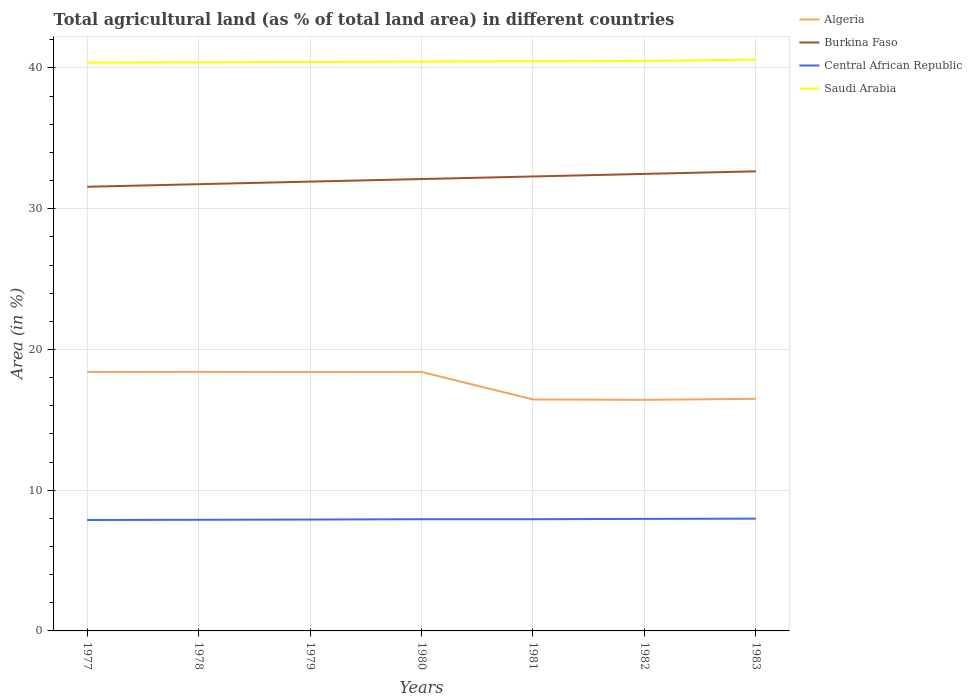How many different coloured lines are there?
Offer a terse response. 4. Does the line corresponding to Burkina Faso intersect with the line corresponding to Saudi Arabia?
Your answer should be very brief. No. Across all years, what is the maximum percentage of agricultural land in Burkina Faso?
Offer a very short reply. 31.56. What is the total percentage of agricultural land in Saudi Arabia in the graph?
Provide a short and direct response. -0.02. What is the difference between the highest and the second highest percentage of agricultural land in Burkina Faso?
Ensure brevity in your answer.  1.1. How many lines are there?
Offer a very short reply. 4. How are the legend labels stacked?
Keep it short and to the point. Vertical. What is the title of the graph?
Offer a very short reply. Total agricultural land (as % of total land area) in different countries. What is the label or title of the Y-axis?
Keep it short and to the point. Area (in %). What is the Area (in %) of Algeria in 1977?
Offer a terse response. 18.4. What is the Area (in %) in Burkina Faso in 1977?
Make the answer very short. 31.56. What is the Area (in %) of Central African Republic in 1977?
Offer a very short reply. 7.88. What is the Area (in %) of Saudi Arabia in 1977?
Provide a succinct answer. 40.38. What is the Area (in %) of Algeria in 1978?
Your answer should be compact. 18.41. What is the Area (in %) in Burkina Faso in 1978?
Your response must be concise. 31.74. What is the Area (in %) of Central African Republic in 1978?
Offer a terse response. 7.9. What is the Area (in %) in Saudi Arabia in 1978?
Keep it short and to the point. 40.4. What is the Area (in %) of Algeria in 1979?
Provide a succinct answer. 18.4. What is the Area (in %) of Burkina Faso in 1979?
Provide a succinct answer. 31.93. What is the Area (in %) of Central African Republic in 1979?
Your response must be concise. 7.91. What is the Area (in %) of Saudi Arabia in 1979?
Offer a very short reply. 40.43. What is the Area (in %) in Algeria in 1980?
Keep it short and to the point. 18.4. What is the Area (in %) of Burkina Faso in 1980?
Ensure brevity in your answer.  32.11. What is the Area (in %) in Central African Republic in 1980?
Make the answer very short. 7.94. What is the Area (in %) of Saudi Arabia in 1980?
Ensure brevity in your answer.  40.45. What is the Area (in %) of Algeria in 1981?
Provide a short and direct response. 16.45. What is the Area (in %) of Burkina Faso in 1981?
Offer a terse response. 32.29. What is the Area (in %) of Central African Republic in 1981?
Provide a succinct answer. 7.94. What is the Area (in %) of Saudi Arabia in 1981?
Keep it short and to the point. 40.48. What is the Area (in %) in Algeria in 1982?
Offer a terse response. 16.42. What is the Area (in %) in Burkina Faso in 1982?
Give a very brief answer. 32.47. What is the Area (in %) in Central African Republic in 1982?
Your answer should be compact. 7.96. What is the Area (in %) of Saudi Arabia in 1982?
Make the answer very short. 40.5. What is the Area (in %) of Algeria in 1983?
Make the answer very short. 16.49. What is the Area (in %) in Burkina Faso in 1983?
Provide a succinct answer. 32.66. What is the Area (in %) in Central African Republic in 1983?
Offer a terse response. 7.98. What is the Area (in %) in Saudi Arabia in 1983?
Ensure brevity in your answer.  40.6. Across all years, what is the maximum Area (in %) of Algeria?
Your answer should be compact. 18.41. Across all years, what is the maximum Area (in %) in Burkina Faso?
Keep it short and to the point. 32.66. Across all years, what is the maximum Area (in %) in Central African Republic?
Ensure brevity in your answer.  7.98. Across all years, what is the maximum Area (in %) of Saudi Arabia?
Offer a terse response. 40.6. Across all years, what is the minimum Area (in %) of Algeria?
Offer a terse response. 16.42. Across all years, what is the minimum Area (in %) of Burkina Faso?
Give a very brief answer. 31.56. Across all years, what is the minimum Area (in %) in Central African Republic?
Make the answer very short. 7.88. Across all years, what is the minimum Area (in %) in Saudi Arabia?
Your response must be concise. 40.38. What is the total Area (in %) in Algeria in the graph?
Give a very brief answer. 122.97. What is the total Area (in %) of Burkina Faso in the graph?
Your response must be concise. 224.76. What is the total Area (in %) of Central African Republic in the graph?
Keep it short and to the point. 55.51. What is the total Area (in %) of Saudi Arabia in the graph?
Keep it short and to the point. 283.24. What is the difference between the Area (in %) in Algeria in 1977 and that in 1978?
Your answer should be very brief. -0. What is the difference between the Area (in %) of Burkina Faso in 1977 and that in 1978?
Offer a very short reply. -0.18. What is the difference between the Area (in %) of Central African Republic in 1977 and that in 1978?
Keep it short and to the point. -0.02. What is the difference between the Area (in %) of Saudi Arabia in 1977 and that in 1978?
Your answer should be compact. -0.02. What is the difference between the Area (in %) in Algeria in 1977 and that in 1979?
Offer a terse response. 0.01. What is the difference between the Area (in %) of Burkina Faso in 1977 and that in 1979?
Ensure brevity in your answer.  -0.37. What is the difference between the Area (in %) in Central African Republic in 1977 and that in 1979?
Ensure brevity in your answer.  -0.03. What is the difference between the Area (in %) of Saudi Arabia in 1977 and that in 1979?
Keep it short and to the point. -0.05. What is the difference between the Area (in %) of Algeria in 1977 and that in 1980?
Offer a terse response. 0. What is the difference between the Area (in %) of Burkina Faso in 1977 and that in 1980?
Provide a succinct answer. -0.55. What is the difference between the Area (in %) of Central African Republic in 1977 and that in 1980?
Provide a succinct answer. -0.06. What is the difference between the Area (in %) of Saudi Arabia in 1977 and that in 1980?
Your answer should be compact. -0.07. What is the difference between the Area (in %) of Algeria in 1977 and that in 1981?
Ensure brevity in your answer.  1.96. What is the difference between the Area (in %) in Burkina Faso in 1977 and that in 1981?
Your answer should be compact. -0.73. What is the difference between the Area (in %) in Central African Republic in 1977 and that in 1981?
Provide a succinct answer. -0.06. What is the difference between the Area (in %) in Saudi Arabia in 1977 and that in 1981?
Ensure brevity in your answer.  -0.1. What is the difference between the Area (in %) in Algeria in 1977 and that in 1982?
Give a very brief answer. 1.98. What is the difference between the Area (in %) of Burkina Faso in 1977 and that in 1982?
Make the answer very short. -0.91. What is the difference between the Area (in %) in Central African Republic in 1977 and that in 1982?
Your response must be concise. -0.08. What is the difference between the Area (in %) of Saudi Arabia in 1977 and that in 1982?
Offer a very short reply. -0.12. What is the difference between the Area (in %) in Algeria in 1977 and that in 1983?
Offer a very short reply. 1.91. What is the difference between the Area (in %) of Burkina Faso in 1977 and that in 1983?
Give a very brief answer. -1.1. What is the difference between the Area (in %) in Central African Republic in 1977 and that in 1983?
Keep it short and to the point. -0.1. What is the difference between the Area (in %) of Saudi Arabia in 1977 and that in 1983?
Keep it short and to the point. -0.22. What is the difference between the Area (in %) of Algeria in 1978 and that in 1979?
Give a very brief answer. 0.01. What is the difference between the Area (in %) in Burkina Faso in 1978 and that in 1979?
Your answer should be compact. -0.18. What is the difference between the Area (in %) of Central African Republic in 1978 and that in 1979?
Provide a short and direct response. -0.02. What is the difference between the Area (in %) of Saudi Arabia in 1978 and that in 1979?
Provide a short and direct response. -0.02. What is the difference between the Area (in %) in Algeria in 1978 and that in 1980?
Give a very brief answer. 0.01. What is the difference between the Area (in %) of Burkina Faso in 1978 and that in 1980?
Make the answer very short. -0.37. What is the difference between the Area (in %) in Central African Republic in 1978 and that in 1980?
Provide a succinct answer. -0.04. What is the difference between the Area (in %) in Saudi Arabia in 1978 and that in 1980?
Provide a short and direct response. -0.05. What is the difference between the Area (in %) in Algeria in 1978 and that in 1981?
Your answer should be very brief. 1.96. What is the difference between the Area (in %) of Burkina Faso in 1978 and that in 1981?
Give a very brief answer. -0.55. What is the difference between the Area (in %) of Central African Republic in 1978 and that in 1981?
Your response must be concise. -0.04. What is the difference between the Area (in %) in Saudi Arabia in 1978 and that in 1981?
Your answer should be compact. -0.07. What is the difference between the Area (in %) of Algeria in 1978 and that in 1982?
Provide a succinct answer. 1.99. What is the difference between the Area (in %) in Burkina Faso in 1978 and that in 1982?
Your answer should be very brief. -0.73. What is the difference between the Area (in %) of Central African Republic in 1978 and that in 1982?
Give a very brief answer. -0.06. What is the difference between the Area (in %) in Saudi Arabia in 1978 and that in 1982?
Your response must be concise. -0.1. What is the difference between the Area (in %) in Algeria in 1978 and that in 1983?
Offer a terse response. 1.92. What is the difference between the Area (in %) of Burkina Faso in 1978 and that in 1983?
Provide a succinct answer. -0.91. What is the difference between the Area (in %) of Central African Republic in 1978 and that in 1983?
Your response must be concise. -0.08. What is the difference between the Area (in %) of Saudi Arabia in 1978 and that in 1983?
Ensure brevity in your answer.  -0.19. What is the difference between the Area (in %) of Algeria in 1979 and that in 1980?
Provide a succinct answer. -0. What is the difference between the Area (in %) of Burkina Faso in 1979 and that in 1980?
Keep it short and to the point. -0.18. What is the difference between the Area (in %) in Central African Republic in 1979 and that in 1980?
Provide a short and direct response. -0.02. What is the difference between the Area (in %) in Saudi Arabia in 1979 and that in 1980?
Offer a terse response. -0.02. What is the difference between the Area (in %) of Algeria in 1979 and that in 1981?
Provide a succinct answer. 1.95. What is the difference between the Area (in %) in Burkina Faso in 1979 and that in 1981?
Provide a succinct answer. -0.37. What is the difference between the Area (in %) of Central African Republic in 1979 and that in 1981?
Make the answer very short. -0.02. What is the difference between the Area (in %) in Saudi Arabia in 1979 and that in 1981?
Offer a terse response. -0.05. What is the difference between the Area (in %) of Algeria in 1979 and that in 1982?
Your answer should be very brief. 1.98. What is the difference between the Area (in %) of Burkina Faso in 1979 and that in 1982?
Ensure brevity in your answer.  -0.55. What is the difference between the Area (in %) in Central African Republic in 1979 and that in 1982?
Offer a terse response. -0.05. What is the difference between the Area (in %) of Saudi Arabia in 1979 and that in 1982?
Offer a very short reply. -0.07. What is the difference between the Area (in %) in Algeria in 1979 and that in 1983?
Provide a succinct answer. 1.91. What is the difference between the Area (in %) in Burkina Faso in 1979 and that in 1983?
Provide a short and direct response. -0.73. What is the difference between the Area (in %) of Central African Republic in 1979 and that in 1983?
Make the answer very short. -0.06. What is the difference between the Area (in %) of Saudi Arabia in 1979 and that in 1983?
Your answer should be compact. -0.17. What is the difference between the Area (in %) in Algeria in 1980 and that in 1981?
Ensure brevity in your answer.  1.96. What is the difference between the Area (in %) of Burkina Faso in 1980 and that in 1981?
Your answer should be compact. -0.18. What is the difference between the Area (in %) in Central African Republic in 1980 and that in 1981?
Provide a short and direct response. 0. What is the difference between the Area (in %) of Saudi Arabia in 1980 and that in 1981?
Ensure brevity in your answer.  -0.02. What is the difference between the Area (in %) in Algeria in 1980 and that in 1982?
Offer a very short reply. 1.98. What is the difference between the Area (in %) in Burkina Faso in 1980 and that in 1982?
Provide a short and direct response. -0.37. What is the difference between the Area (in %) of Central African Republic in 1980 and that in 1982?
Your answer should be very brief. -0.02. What is the difference between the Area (in %) of Saudi Arabia in 1980 and that in 1982?
Your answer should be compact. -0.05. What is the difference between the Area (in %) of Algeria in 1980 and that in 1983?
Give a very brief answer. 1.91. What is the difference between the Area (in %) in Burkina Faso in 1980 and that in 1983?
Offer a terse response. -0.55. What is the difference between the Area (in %) in Central African Republic in 1980 and that in 1983?
Your response must be concise. -0.04. What is the difference between the Area (in %) in Saudi Arabia in 1980 and that in 1983?
Provide a short and direct response. -0.14. What is the difference between the Area (in %) in Algeria in 1981 and that in 1982?
Offer a terse response. 0.03. What is the difference between the Area (in %) of Burkina Faso in 1981 and that in 1982?
Offer a very short reply. -0.18. What is the difference between the Area (in %) of Central African Republic in 1981 and that in 1982?
Make the answer very short. -0.02. What is the difference between the Area (in %) in Saudi Arabia in 1981 and that in 1982?
Provide a succinct answer. -0.03. What is the difference between the Area (in %) in Algeria in 1981 and that in 1983?
Offer a terse response. -0.05. What is the difference between the Area (in %) of Burkina Faso in 1981 and that in 1983?
Give a very brief answer. -0.37. What is the difference between the Area (in %) in Central African Republic in 1981 and that in 1983?
Offer a very short reply. -0.04. What is the difference between the Area (in %) in Saudi Arabia in 1981 and that in 1983?
Keep it short and to the point. -0.12. What is the difference between the Area (in %) of Algeria in 1982 and that in 1983?
Offer a very short reply. -0.07. What is the difference between the Area (in %) of Burkina Faso in 1982 and that in 1983?
Provide a short and direct response. -0.18. What is the difference between the Area (in %) of Central African Republic in 1982 and that in 1983?
Your answer should be very brief. -0.02. What is the difference between the Area (in %) in Saudi Arabia in 1982 and that in 1983?
Your answer should be compact. -0.09. What is the difference between the Area (in %) in Algeria in 1977 and the Area (in %) in Burkina Faso in 1978?
Give a very brief answer. -13.34. What is the difference between the Area (in %) of Algeria in 1977 and the Area (in %) of Central African Republic in 1978?
Offer a very short reply. 10.51. What is the difference between the Area (in %) of Algeria in 1977 and the Area (in %) of Saudi Arabia in 1978?
Offer a very short reply. -22. What is the difference between the Area (in %) in Burkina Faso in 1977 and the Area (in %) in Central African Republic in 1978?
Your answer should be compact. 23.66. What is the difference between the Area (in %) in Burkina Faso in 1977 and the Area (in %) in Saudi Arabia in 1978?
Offer a very short reply. -8.84. What is the difference between the Area (in %) in Central African Republic in 1977 and the Area (in %) in Saudi Arabia in 1978?
Your answer should be compact. -32.52. What is the difference between the Area (in %) of Algeria in 1977 and the Area (in %) of Burkina Faso in 1979?
Your answer should be compact. -13.52. What is the difference between the Area (in %) of Algeria in 1977 and the Area (in %) of Central African Republic in 1979?
Offer a terse response. 10.49. What is the difference between the Area (in %) of Algeria in 1977 and the Area (in %) of Saudi Arabia in 1979?
Provide a short and direct response. -22.03. What is the difference between the Area (in %) of Burkina Faso in 1977 and the Area (in %) of Central African Republic in 1979?
Provide a short and direct response. 23.65. What is the difference between the Area (in %) of Burkina Faso in 1977 and the Area (in %) of Saudi Arabia in 1979?
Offer a very short reply. -8.87. What is the difference between the Area (in %) of Central African Republic in 1977 and the Area (in %) of Saudi Arabia in 1979?
Your response must be concise. -32.55. What is the difference between the Area (in %) of Algeria in 1977 and the Area (in %) of Burkina Faso in 1980?
Ensure brevity in your answer.  -13.71. What is the difference between the Area (in %) of Algeria in 1977 and the Area (in %) of Central African Republic in 1980?
Make the answer very short. 10.47. What is the difference between the Area (in %) in Algeria in 1977 and the Area (in %) in Saudi Arabia in 1980?
Offer a terse response. -22.05. What is the difference between the Area (in %) of Burkina Faso in 1977 and the Area (in %) of Central African Republic in 1980?
Give a very brief answer. 23.62. What is the difference between the Area (in %) of Burkina Faso in 1977 and the Area (in %) of Saudi Arabia in 1980?
Your response must be concise. -8.89. What is the difference between the Area (in %) in Central African Republic in 1977 and the Area (in %) in Saudi Arabia in 1980?
Offer a very short reply. -32.57. What is the difference between the Area (in %) of Algeria in 1977 and the Area (in %) of Burkina Faso in 1981?
Provide a short and direct response. -13.89. What is the difference between the Area (in %) of Algeria in 1977 and the Area (in %) of Central African Republic in 1981?
Offer a very short reply. 10.47. What is the difference between the Area (in %) of Algeria in 1977 and the Area (in %) of Saudi Arabia in 1981?
Make the answer very short. -22.07. What is the difference between the Area (in %) in Burkina Faso in 1977 and the Area (in %) in Central African Republic in 1981?
Your answer should be very brief. 23.62. What is the difference between the Area (in %) in Burkina Faso in 1977 and the Area (in %) in Saudi Arabia in 1981?
Your answer should be compact. -8.92. What is the difference between the Area (in %) of Central African Republic in 1977 and the Area (in %) of Saudi Arabia in 1981?
Keep it short and to the point. -32.6. What is the difference between the Area (in %) of Algeria in 1977 and the Area (in %) of Burkina Faso in 1982?
Your response must be concise. -14.07. What is the difference between the Area (in %) of Algeria in 1977 and the Area (in %) of Central African Republic in 1982?
Ensure brevity in your answer.  10.44. What is the difference between the Area (in %) of Algeria in 1977 and the Area (in %) of Saudi Arabia in 1982?
Ensure brevity in your answer.  -22.1. What is the difference between the Area (in %) in Burkina Faso in 1977 and the Area (in %) in Central African Republic in 1982?
Offer a terse response. 23.6. What is the difference between the Area (in %) in Burkina Faso in 1977 and the Area (in %) in Saudi Arabia in 1982?
Your answer should be very brief. -8.94. What is the difference between the Area (in %) in Central African Republic in 1977 and the Area (in %) in Saudi Arabia in 1982?
Make the answer very short. -32.62. What is the difference between the Area (in %) in Algeria in 1977 and the Area (in %) in Burkina Faso in 1983?
Keep it short and to the point. -14.25. What is the difference between the Area (in %) of Algeria in 1977 and the Area (in %) of Central African Republic in 1983?
Your response must be concise. 10.43. What is the difference between the Area (in %) in Algeria in 1977 and the Area (in %) in Saudi Arabia in 1983?
Offer a very short reply. -22.19. What is the difference between the Area (in %) of Burkina Faso in 1977 and the Area (in %) of Central African Republic in 1983?
Your answer should be compact. 23.58. What is the difference between the Area (in %) in Burkina Faso in 1977 and the Area (in %) in Saudi Arabia in 1983?
Give a very brief answer. -9.04. What is the difference between the Area (in %) in Central African Republic in 1977 and the Area (in %) in Saudi Arabia in 1983?
Provide a short and direct response. -32.72. What is the difference between the Area (in %) in Algeria in 1978 and the Area (in %) in Burkina Faso in 1979?
Provide a succinct answer. -13.52. What is the difference between the Area (in %) of Algeria in 1978 and the Area (in %) of Central African Republic in 1979?
Provide a succinct answer. 10.49. What is the difference between the Area (in %) of Algeria in 1978 and the Area (in %) of Saudi Arabia in 1979?
Offer a terse response. -22.02. What is the difference between the Area (in %) of Burkina Faso in 1978 and the Area (in %) of Central African Republic in 1979?
Provide a short and direct response. 23.83. What is the difference between the Area (in %) in Burkina Faso in 1978 and the Area (in %) in Saudi Arabia in 1979?
Give a very brief answer. -8.69. What is the difference between the Area (in %) of Central African Republic in 1978 and the Area (in %) of Saudi Arabia in 1979?
Your answer should be very brief. -32.53. What is the difference between the Area (in %) in Algeria in 1978 and the Area (in %) in Burkina Faso in 1980?
Ensure brevity in your answer.  -13.7. What is the difference between the Area (in %) of Algeria in 1978 and the Area (in %) of Central African Republic in 1980?
Your response must be concise. 10.47. What is the difference between the Area (in %) in Algeria in 1978 and the Area (in %) in Saudi Arabia in 1980?
Provide a succinct answer. -22.05. What is the difference between the Area (in %) in Burkina Faso in 1978 and the Area (in %) in Central African Republic in 1980?
Your answer should be very brief. 23.81. What is the difference between the Area (in %) in Burkina Faso in 1978 and the Area (in %) in Saudi Arabia in 1980?
Give a very brief answer. -8.71. What is the difference between the Area (in %) of Central African Republic in 1978 and the Area (in %) of Saudi Arabia in 1980?
Provide a short and direct response. -32.56. What is the difference between the Area (in %) in Algeria in 1978 and the Area (in %) in Burkina Faso in 1981?
Your response must be concise. -13.88. What is the difference between the Area (in %) in Algeria in 1978 and the Area (in %) in Central African Republic in 1981?
Offer a terse response. 10.47. What is the difference between the Area (in %) of Algeria in 1978 and the Area (in %) of Saudi Arabia in 1981?
Provide a short and direct response. -22.07. What is the difference between the Area (in %) of Burkina Faso in 1978 and the Area (in %) of Central African Republic in 1981?
Provide a succinct answer. 23.81. What is the difference between the Area (in %) in Burkina Faso in 1978 and the Area (in %) in Saudi Arabia in 1981?
Keep it short and to the point. -8.73. What is the difference between the Area (in %) in Central African Republic in 1978 and the Area (in %) in Saudi Arabia in 1981?
Offer a very short reply. -32.58. What is the difference between the Area (in %) in Algeria in 1978 and the Area (in %) in Burkina Faso in 1982?
Your answer should be compact. -14.07. What is the difference between the Area (in %) in Algeria in 1978 and the Area (in %) in Central African Republic in 1982?
Provide a succinct answer. 10.45. What is the difference between the Area (in %) in Algeria in 1978 and the Area (in %) in Saudi Arabia in 1982?
Your response must be concise. -22.09. What is the difference between the Area (in %) in Burkina Faso in 1978 and the Area (in %) in Central African Republic in 1982?
Provide a short and direct response. 23.78. What is the difference between the Area (in %) of Burkina Faso in 1978 and the Area (in %) of Saudi Arabia in 1982?
Your response must be concise. -8.76. What is the difference between the Area (in %) in Central African Republic in 1978 and the Area (in %) in Saudi Arabia in 1982?
Your response must be concise. -32.61. What is the difference between the Area (in %) of Algeria in 1978 and the Area (in %) of Burkina Faso in 1983?
Offer a terse response. -14.25. What is the difference between the Area (in %) of Algeria in 1978 and the Area (in %) of Central African Republic in 1983?
Ensure brevity in your answer.  10.43. What is the difference between the Area (in %) of Algeria in 1978 and the Area (in %) of Saudi Arabia in 1983?
Ensure brevity in your answer.  -22.19. What is the difference between the Area (in %) in Burkina Faso in 1978 and the Area (in %) in Central African Republic in 1983?
Your response must be concise. 23.77. What is the difference between the Area (in %) in Burkina Faso in 1978 and the Area (in %) in Saudi Arabia in 1983?
Keep it short and to the point. -8.85. What is the difference between the Area (in %) in Central African Republic in 1978 and the Area (in %) in Saudi Arabia in 1983?
Offer a terse response. -32.7. What is the difference between the Area (in %) in Algeria in 1979 and the Area (in %) in Burkina Faso in 1980?
Your answer should be compact. -13.71. What is the difference between the Area (in %) of Algeria in 1979 and the Area (in %) of Central African Republic in 1980?
Ensure brevity in your answer.  10.46. What is the difference between the Area (in %) in Algeria in 1979 and the Area (in %) in Saudi Arabia in 1980?
Ensure brevity in your answer.  -22.05. What is the difference between the Area (in %) of Burkina Faso in 1979 and the Area (in %) of Central African Republic in 1980?
Offer a terse response. 23.99. What is the difference between the Area (in %) of Burkina Faso in 1979 and the Area (in %) of Saudi Arabia in 1980?
Offer a very short reply. -8.53. What is the difference between the Area (in %) in Central African Republic in 1979 and the Area (in %) in Saudi Arabia in 1980?
Keep it short and to the point. -32.54. What is the difference between the Area (in %) in Algeria in 1979 and the Area (in %) in Burkina Faso in 1981?
Keep it short and to the point. -13.89. What is the difference between the Area (in %) in Algeria in 1979 and the Area (in %) in Central African Republic in 1981?
Provide a succinct answer. 10.46. What is the difference between the Area (in %) of Algeria in 1979 and the Area (in %) of Saudi Arabia in 1981?
Your response must be concise. -22.08. What is the difference between the Area (in %) in Burkina Faso in 1979 and the Area (in %) in Central African Republic in 1981?
Give a very brief answer. 23.99. What is the difference between the Area (in %) of Burkina Faso in 1979 and the Area (in %) of Saudi Arabia in 1981?
Keep it short and to the point. -8.55. What is the difference between the Area (in %) of Central African Republic in 1979 and the Area (in %) of Saudi Arabia in 1981?
Offer a very short reply. -32.56. What is the difference between the Area (in %) in Algeria in 1979 and the Area (in %) in Burkina Faso in 1982?
Offer a very short reply. -14.08. What is the difference between the Area (in %) of Algeria in 1979 and the Area (in %) of Central African Republic in 1982?
Give a very brief answer. 10.44. What is the difference between the Area (in %) of Algeria in 1979 and the Area (in %) of Saudi Arabia in 1982?
Give a very brief answer. -22.1. What is the difference between the Area (in %) of Burkina Faso in 1979 and the Area (in %) of Central African Republic in 1982?
Offer a terse response. 23.96. What is the difference between the Area (in %) in Burkina Faso in 1979 and the Area (in %) in Saudi Arabia in 1982?
Give a very brief answer. -8.58. What is the difference between the Area (in %) of Central African Republic in 1979 and the Area (in %) of Saudi Arabia in 1982?
Offer a very short reply. -32.59. What is the difference between the Area (in %) in Algeria in 1979 and the Area (in %) in Burkina Faso in 1983?
Keep it short and to the point. -14.26. What is the difference between the Area (in %) of Algeria in 1979 and the Area (in %) of Central African Republic in 1983?
Keep it short and to the point. 10.42. What is the difference between the Area (in %) of Algeria in 1979 and the Area (in %) of Saudi Arabia in 1983?
Give a very brief answer. -22.2. What is the difference between the Area (in %) in Burkina Faso in 1979 and the Area (in %) in Central African Republic in 1983?
Give a very brief answer. 23.95. What is the difference between the Area (in %) in Burkina Faso in 1979 and the Area (in %) in Saudi Arabia in 1983?
Offer a terse response. -8.67. What is the difference between the Area (in %) in Central African Republic in 1979 and the Area (in %) in Saudi Arabia in 1983?
Offer a terse response. -32.68. What is the difference between the Area (in %) of Algeria in 1980 and the Area (in %) of Burkina Faso in 1981?
Ensure brevity in your answer.  -13.89. What is the difference between the Area (in %) in Algeria in 1980 and the Area (in %) in Central African Republic in 1981?
Provide a short and direct response. 10.46. What is the difference between the Area (in %) in Algeria in 1980 and the Area (in %) in Saudi Arabia in 1981?
Your answer should be very brief. -22.07. What is the difference between the Area (in %) in Burkina Faso in 1980 and the Area (in %) in Central African Republic in 1981?
Give a very brief answer. 24.17. What is the difference between the Area (in %) of Burkina Faso in 1980 and the Area (in %) of Saudi Arabia in 1981?
Your response must be concise. -8.37. What is the difference between the Area (in %) of Central African Republic in 1980 and the Area (in %) of Saudi Arabia in 1981?
Make the answer very short. -32.54. What is the difference between the Area (in %) of Algeria in 1980 and the Area (in %) of Burkina Faso in 1982?
Ensure brevity in your answer.  -14.07. What is the difference between the Area (in %) of Algeria in 1980 and the Area (in %) of Central African Republic in 1982?
Provide a succinct answer. 10.44. What is the difference between the Area (in %) of Algeria in 1980 and the Area (in %) of Saudi Arabia in 1982?
Offer a terse response. -22.1. What is the difference between the Area (in %) in Burkina Faso in 1980 and the Area (in %) in Central African Republic in 1982?
Your answer should be compact. 24.15. What is the difference between the Area (in %) of Burkina Faso in 1980 and the Area (in %) of Saudi Arabia in 1982?
Provide a succinct answer. -8.39. What is the difference between the Area (in %) in Central African Republic in 1980 and the Area (in %) in Saudi Arabia in 1982?
Provide a succinct answer. -32.56. What is the difference between the Area (in %) in Algeria in 1980 and the Area (in %) in Burkina Faso in 1983?
Your answer should be very brief. -14.25. What is the difference between the Area (in %) of Algeria in 1980 and the Area (in %) of Central African Republic in 1983?
Give a very brief answer. 10.42. What is the difference between the Area (in %) of Algeria in 1980 and the Area (in %) of Saudi Arabia in 1983?
Make the answer very short. -22.19. What is the difference between the Area (in %) of Burkina Faso in 1980 and the Area (in %) of Central African Republic in 1983?
Offer a very short reply. 24.13. What is the difference between the Area (in %) in Burkina Faso in 1980 and the Area (in %) in Saudi Arabia in 1983?
Ensure brevity in your answer.  -8.49. What is the difference between the Area (in %) in Central African Republic in 1980 and the Area (in %) in Saudi Arabia in 1983?
Make the answer very short. -32.66. What is the difference between the Area (in %) of Algeria in 1981 and the Area (in %) of Burkina Faso in 1982?
Offer a very short reply. -16.03. What is the difference between the Area (in %) in Algeria in 1981 and the Area (in %) in Central African Republic in 1982?
Your answer should be compact. 8.48. What is the difference between the Area (in %) in Algeria in 1981 and the Area (in %) in Saudi Arabia in 1982?
Offer a terse response. -24.06. What is the difference between the Area (in %) in Burkina Faso in 1981 and the Area (in %) in Central African Republic in 1982?
Your answer should be very brief. 24.33. What is the difference between the Area (in %) of Burkina Faso in 1981 and the Area (in %) of Saudi Arabia in 1982?
Ensure brevity in your answer.  -8.21. What is the difference between the Area (in %) of Central African Republic in 1981 and the Area (in %) of Saudi Arabia in 1982?
Your response must be concise. -32.56. What is the difference between the Area (in %) in Algeria in 1981 and the Area (in %) in Burkina Faso in 1983?
Ensure brevity in your answer.  -16.21. What is the difference between the Area (in %) in Algeria in 1981 and the Area (in %) in Central African Republic in 1983?
Offer a terse response. 8.47. What is the difference between the Area (in %) in Algeria in 1981 and the Area (in %) in Saudi Arabia in 1983?
Keep it short and to the point. -24.15. What is the difference between the Area (in %) of Burkina Faso in 1981 and the Area (in %) of Central African Republic in 1983?
Make the answer very short. 24.31. What is the difference between the Area (in %) in Burkina Faso in 1981 and the Area (in %) in Saudi Arabia in 1983?
Provide a succinct answer. -8.3. What is the difference between the Area (in %) in Central African Republic in 1981 and the Area (in %) in Saudi Arabia in 1983?
Ensure brevity in your answer.  -32.66. What is the difference between the Area (in %) of Algeria in 1982 and the Area (in %) of Burkina Faso in 1983?
Offer a very short reply. -16.24. What is the difference between the Area (in %) of Algeria in 1982 and the Area (in %) of Central African Republic in 1983?
Keep it short and to the point. 8.44. What is the difference between the Area (in %) in Algeria in 1982 and the Area (in %) in Saudi Arabia in 1983?
Your answer should be very brief. -24.18. What is the difference between the Area (in %) in Burkina Faso in 1982 and the Area (in %) in Central African Republic in 1983?
Give a very brief answer. 24.5. What is the difference between the Area (in %) of Burkina Faso in 1982 and the Area (in %) of Saudi Arabia in 1983?
Offer a very short reply. -8.12. What is the difference between the Area (in %) of Central African Republic in 1982 and the Area (in %) of Saudi Arabia in 1983?
Your answer should be very brief. -32.63. What is the average Area (in %) of Algeria per year?
Ensure brevity in your answer.  17.57. What is the average Area (in %) in Burkina Faso per year?
Ensure brevity in your answer.  32.11. What is the average Area (in %) of Central African Republic per year?
Offer a terse response. 7.93. What is the average Area (in %) of Saudi Arabia per year?
Offer a very short reply. 40.46. In the year 1977, what is the difference between the Area (in %) of Algeria and Area (in %) of Burkina Faso?
Your answer should be very brief. -13.16. In the year 1977, what is the difference between the Area (in %) in Algeria and Area (in %) in Central African Republic?
Your answer should be compact. 10.52. In the year 1977, what is the difference between the Area (in %) of Algeria and Area (in %) of Saudi Arabia?
Provide a short and direct response. -21.98. In the year 1977, what is the difference between the Area (in %) in Burkina Faso and Area (in %) in Central African Republic?
Ensure brevity in your answer.  23.68. In the year 1977, what is the difference between the Area (in %) in Burkina Faso and Area (in %) in Saudi Arabia?
Your response must be concise. -8.82. In the year 1977, what is the difference between the Area (in %) in Central African Republic and Area (in %) in Saudi Arabia?
Keep it short and to the point. -32.5. In the year 1978, what is the difference between the Area (in %) of Algeria and Area (in %) of Burkina Faso?
Provide a succinct answer. -13.34. In the year 1978, what is the difference between the Area (in %) of Algeria and Area (in %) of Central African Republic?
Your answer should be very brief. 10.51. In the year 1978, what is the difference between the Area (in %) of Algeria and Area (in %) of Saudi Arabia?
Make the answer very short. -22. In the year 1978, what is the difference between the Area (in %) in Burkina Faso and Area (in %) in Central African Republic?
Offer a very short reply. 23.85. In the year 1978, what is the difference between the Area (in %) of Burkina Faso and Area (in %) of Saudi Arabia?
Your answer should be compact. -8.66. In the year 1978, what is the difference between the Area (in %) of Central African Republic and Area (in %) of Saudi Arabia?
Keep it short and to the point. -32.51. In the year 1979, what is the difference between the Area (in %) of Algeria and Area (in %) of Burkina Faso?
Make the answer very short. -13.53. In the year 1979, what is the difference between the Area (in %) of Algeria and Area (in %) of Central African Republic?
Give a very brief answer. 10.48. In the year 1979, what is the difference between the Area (in %) in Algeria and Area (in %) in Saudi Arabia?
Offer a very short reply. -22.03. In the year 1979, what is the difference between the Area (in %) in Burkina Faso and Area (in %) in Central African Republic?
Your answer should be compact. 24.01. In the year 1979, what is the difference between the Area (in %) of Burkina Faso and Area (in %) of Saudi Arabia?
Give a very brief answer. -8.5. In the year 1979, what is the difference between the Area (in %) in Central African Republic and Area (in %) in Saudi Arabia?
Make the answer very short. -32.52. In the year 1980, what is the difference between the Area (in %) in Algeria and Area (in %) in Burkina Faso?
Give a very brief answer. -13.71. In the year 1980, what is the difference between the Area (in %) in Algeria and Area (in %) in Central African Republic?
Make the answer very short. 10.46. In the year 1980, what is the difference between the Area (in %) in Algeria and Area (in %) in Saudi Arabia?
Give a very brief answer. -22.05. In the year 1980, what is the difference between the Area (in %) of Burkina Faso and Area (in %) of Central African Republic?
Your answer should be compact. 24.17. In the year 1980, what is the difference between the Area (in %) in Burkina Faso and Area (in %) in Saudi Arabia?
Your response must be concise. -8.34. In the year 1980, what is the difference between the Area (in %) of Central African Republic and Area (in %) of Saudi Arabia?
Give a very brief answer. -32.52. In the year 1981, what is the difference between the Area (in %) in Algeria and Area (in %) in Burkina Faso?
Your answer should be compact. -15.85. In the year 1981, what is the difference between the Area (in %) in Algeria and Area (in %) in Central African Republic?
Ensure brevity in your answer.  8.51. In the year 1981, what is the difference between the Area (in %) in Algeria and Area (in %) in Saudi Arabia?
Your answer should be very brief. -24.03. In the year 1981, what is the difference between the Area (in %) of Burkina Faso and Area (in %) of Central African Republic?
Your answer should be very brief. 24.35. In the year 1981, what is the difference between the Area (in %) of Burkina Faso and Area (in %) of Saudi Arabia?
Your answer should be compact. -8.19. In the year 1981, what is the difference between the Area (in %) of Central African Republic and Area (in %) of Saudi Arabia?
Provide a succinct answer. -32.54. In the year 1982, what is the difference between the Area (in %) of Algeria and Area (in %) of Burkina Faso?
Offer a terse response. -16.05. In the year 1982, what is the difference between the Area (in %) in Algeria and Area (in %) in Central African Republic?
Ensure brevity in your answer.  8.46. In the year 1982, what is the difference between the Area (in %) of Algeria and Area (in %) of Saudi Arabia?
Keep it short and to the point. -24.08. In the year 1982, what is the difference between the Area (in %) of Burkina Faso and Area (in %) of Central African Republic?
Keep it short and to the point. 24.51. In the year 1982, what is the difference between the Area (in %) of Burkina Faso and Area (in %) of Saudi Arabia?
Ensure brevity in your answer.  -8.03. In the year 1982, what is the difference between the Area (in %) in Central African Republic and Area (in %) in Saudi Arabia?
Give a very brief answer. -32.54. In the year 1983, what is the difference between the Area (in %) in Algeria and Area (in %) in Burkina Faso?
Provide a succinct answer. -16.16. In the year 1983, what is the difference between the Area (in %) in Algeria and Area (in %) in Central African Republic?
Offer a very short reply. 8.52. In the year 1983, what is the difference between the Area (in %) in Algeria and Area (in %) in Saudi Arabia?
Offer a terse response. -24.1. In the year 1983, what is the difference between the Area (in %) of Burkina Faso and Area (in %) of Central African Republic?
Your response must be concise. 24.68. In the year 1983, what is the difference between the Area (in %) in Burkina Faso and Area (in %) in Saudi Arabia?
Your response must be concise. -7.94. In the year 1983, what is the difference between the Area (in %) of Central African Republic and Area (in %) of Saudi Arabia?
Provide a succinct answer. -32.62. What is the ratio of the Area (in %) in Burkina Faso in 1977 to that in 1978?
Offer a very short reply. 0.99. What is the ratio of the Area (in %) in Central African Republic in 1977 to that in 1978?
Provide a succinct answer. 1. What is the ratio of the Area (in %) in Saudi Arabia in 1977 to that in 1978?
Offer a very short reply. 1. What is the ratio of the Area (in %) of Algeria in 1977 to that in 1979?
Give a very brief answer. 1. What is the ratio of the Area (in %) in Burkina Faso in 1977 to that in 1979?
Keep it short and to the point. 0.99. What is the ratio of the Area (in %) in Algeria in 1977 to that in 1980?
Make the answer very short. 1. What is the ratio of the Area (in %) in Burkina Faso in 1977 to that in 1980?
Give a very brief answer. 0.98. What is the ratio of the Area (in %) in Central African Republic in 1977 to that in 1980?
Provide a short and direct response. 0.99. What is the ratio of the Area (in %) in Saudi Arabia in 1977 to that in 1980?
Your answer should be very brief. 1. What is the ratio of the Area (in %) of Algeria in 1977 to that in 1981?
Offer a terse response. 1.12. What is the ratio of the Area (in %) in Burkina Faso in 1977 to that in 1981?
Offer a very short reply. 0.98. What is the ratio of the Area (in %) in Saudi Arabia in 1977 to that in 1981?
Provide a short and direct response. 1. What is the ratio of the Area (in %) of Algeria in 1977 to that in 1982?
Ensure brevity in your answer.  1.12. What is the ratio of the Area (in %) in Burkina Faso in 1977 to that in 1982?
Offer a terse response. 0.97. What is the ratio of the Area (in %) of Algeria in 1977 to that in 1983?
Give a very brief answer. 1.12. What is the ratio of the Area (in %) of Burkina Faso in 1977 to that in 1983?
Your answer should be very brief. 0.97. What is the ratio of the Area (in %) in Central African Republic in 1977 to that in 1983?
Keep it short and to the point. 0.99. What is the ratio of the Area (in %) in Burkina Faso in 1978 to that in 1979?
Make the answer very short. 0.99. What is the ratio of the Area (in %) in Central African Republic in 1978 to that in 1979?
Ensure brevity in your answer.  1. What is the ratio of the Area (in %) of Saudi Arabia in 1978 to that in 1979?
Keep it short and to the point. 1. What is the ratio of the Area (in %) in Algeria in 1978 to that in 1980?
Offer a very short reply. 1. What is the ratio of the Area (in %) of Algeria in 1978 to that in 1981?
Make the answer very short. 1.12. What is the ratio of the Area (in %) of Burkina Faso in 1978 to that in 1981?
Make the answer very short. 0.98. What is the ratio of the Area (in %) of Central African Republic in 1978 to that in 1981?
Give a very brief answer. 0.99. What is the ratio of the Area (in %) of Algeria in 1978 to that in 1982?
Keep it short and to the point. 1.12. What is the ratio of the Area (in %) in Burkina Faso in 1978 to that in 1982?
Provide a short and direct response. 0.98. What is the ratio of the Area (in %) in Algeria in 1978 to that in 1983?
Offer a very short reply. 1.12. What is the ratio of the Area (in %) in Burkina Faso in 1978 to that in 1983?
Make the answer very short. 0.97. What is the ratio of the Area (in %) of Saudi Arabia in 1978 to that in 1983?
Your answer should be compact. 1. What is the ratio of the Area (in %) in Algeria in 1979 to that in 1980?
Keep it short and to the point. 1. What is the ratio of the Area (in %) in Burkina Faso in 1979 to that in 1980?
Offer a terse response. 0.99. What is the ratio of the Area (in %) in Central African Republic in 1979 to that in 1980?
Your answer should be compact. 1. What is the ratio of the Area (in %) in Saudi Arabia in 1979 to that in 1980?
Offer a very short reply. 1. What is the ratio of the Area (in %) in Algeria in 1979 to that in 1981?
Ensure brevity in your answer.  1.12. What is the ratio of the Area (in %) of Burkina Faso in 1979 to that in 1981?
Your response must be concise. 0.99. What is the ratio of the Area (in %) in Central African Republic in 1979 to that in 1981?
Ensure brevity in your answer.  1. What is the ratio of the Area (in %) of Algeria in 1979 to that in 1982?
Make the answer very short. 1.12. What is the ratio of the Area (in %) in Burkina Faso in 1979 to that in 1982?
Offer a terse response. 0.98. What is the ratio of the Area (in %) of Central African Republic in 1979 to that in 1982?
Offer a very short reply. 0.99. What is the ratio of the Area (in %) of Algeria in 1979 to that in 1983?
Provide a succinct answer. 1.12. What is the ratio of the Area (in %) of Burkina Faso in 1979 to that in 1983?
Your answer should be very brief. 0.98. What is the ratio of the Area (in %) of Algeria in 1980 to that in 1981?
Keep it short and to the point. 1.12. What is the ratio of the Area (in %) of Saudi Arabia in 1980 to that in 1981?
Offer a very short reply. 1. What is the ratio of the Area (in %) in Algeria in 1980 to that in 1982?
Give a very brief answer. 1.12. What is the ratio of the Area (in %) of Burkina Faso in 1980 to that in 1982?
Keep it short and to the point. 0.99. What is the ratio of the Area (in %) in Algeria in 1980 to that in 1983?
Provide a short and direct response. 1.12. What is the ratio of the Area (in %) of Burkina Faso in 1980 to that in 1983?
Your response must be concise. 0.98. What is the ratio of the Area (in %) of Saudi Arabia in 1980 to that in 1983?
Ensure brevity in your answer.  1. What is the ratio of the Area (in %) in Burkina Faso in 1981 to that in 1982?
Make the answer very short. 0.99. What is the ratio of the Area (in %) of Central African Republic in 1981 to that in 1982?
Offer a terse response. 1. What is the ratio of the Area (in %) of Saudi Arabia in 1981 to that in 1982?
Ensure brevity in your answer.  1. What is the ratio of the Area (in %) in Central African Republic in 1981 to that in 1983?
Your answer should be compact. 0.99. What is the ratio of the Area (in %) in Saudi Arabia in 1981 to that in 1983?
Offer a very short reply. 1. What is the ratio of the Area (in %) in Burkina Faso in 1982 to that in 1983?
Ensure brevity in your answer.  0.99. What is the difference between the highest and the second highest Area (in %) of Algeria?
Your answer should be very brief. 0. What is the difference between the highest and the second highest Area (in %) in Burkina Faso?
Your answer should be very brief. 0.18. What is the difference between the highest and the second highest Area (in %) in Central African Republic?
Make the answer very short. 0.02. What is the difference between the highest and the second highest Area (in %) of Saudi Arabia?
Provide a short and direct response. 0.09. What is the difference between the highest and the lowest Area (in %) of Algeria?
Ensure brevity in your answer.  1.99. What is the difference between the highest and the lowest Area (in %) in Burkina Faso?
Make the answer very short. 1.1. What is the difference between the highest and the lowest Area (in %) of Central African Republic?
Provide a short and direct response. 0.1. What is the difference between the highest and the lowest Area (in %) in Saudi Arabia?
Your response must be concise. 0.22. 